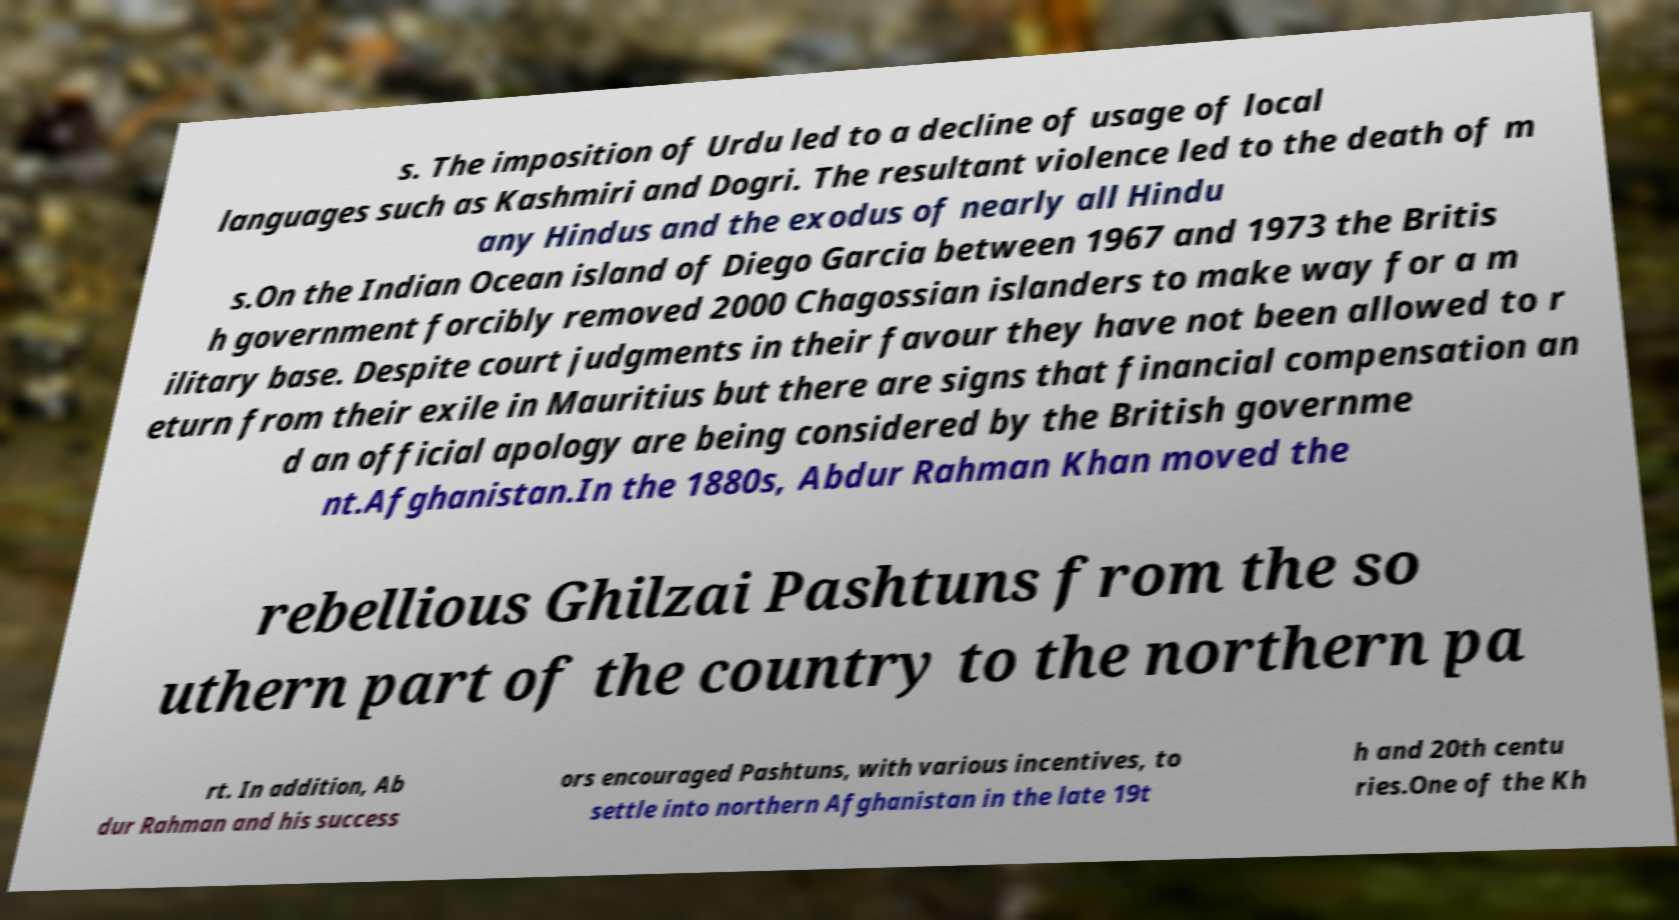There's text embedded in this image that I need extracted. Can you transcribe it verbatim? s. The imposition of Urdu led to a decline of usage of local languages such as Kashmiri and Dogri. The resultant violence led to the death of m any Hindus and the exodus of nearly all Hindu s.On the Indian Ocean island of Diego Garcia between 1967 and 1973 the Britis h government forcibly removed 2000 Chagossian islanders to make way for a m ilitary base. Despite court judgments in their favour they have not been allowed to r eturn from their exile in Mauritius but there are signs that financial compensation an d an official apology are being considered by the British governme nt.Afghanistan.In the 1880s, Abdur Rahman Khan moved the rebellious Ghilzai Pashtuns from the so uthern part of the country to the northern pa rt. In addition, Ab dur Rahman and his success ors encouraged Pashtuns, with various incentives, to settle into northern Afghanistan in the late 19t h and 20th centu ries.One of the Kh 